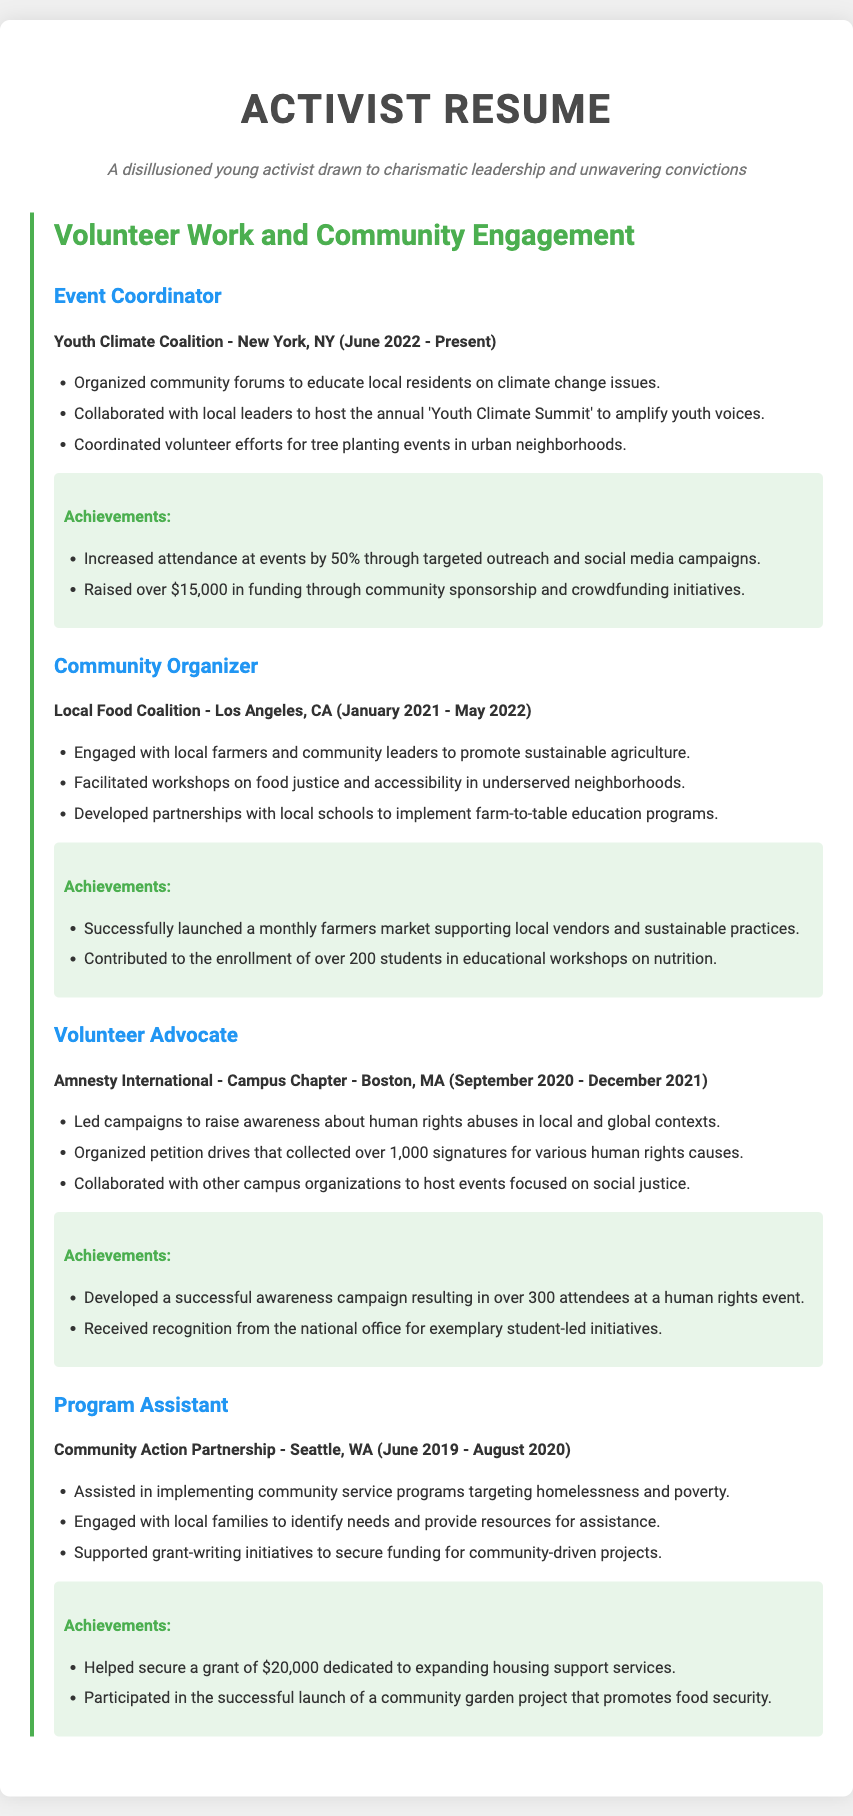what is the title of the resume? The title of the resume is prominently displayed at the top and states "Activist Resume."
Answer: Activist Resume who is the current Event Coordinator? The current Event Coordinator is associated with the Youth Climate Coalition in New York, NY.
Answer: Youth Climate Coalition how much funding has been raised by the Event Coordinator? The document states that the Event Coordinator raised over $15,000 in funding.
Answer: $15,000 what is the achievement of the Community Organizer related to students? The Community Organizer contributed to the enrollment of over 200 students in educational workshops.
Answer: 200 students which organization hosted a human rights event? The organization that hosted a human rights event is Amnesty International - Campus Chapter.
Answer: Amnesty International - Campus Chapter what was the focus of the workshops facilitated by the Community Organizer? The workshops facilitated by the Community Organizer focused on food justice and accessibility.
Answer: food justice and accessibility in which city is the Community Action Partnership located? The Community Action Partnership is located in Seattle, WA.
Answer: Seattle, WA how many signatures were collected during the petition drives led by the Volunteer Advocate? The petition drives organized by the Volunteer Advocate collected over 1,000 signatures.
Answer: 1,000 signatures what major project was launched under the Program Assistant’s achievements? A major project launched was a community garden project that promotes food security.
Answer: community garden project 